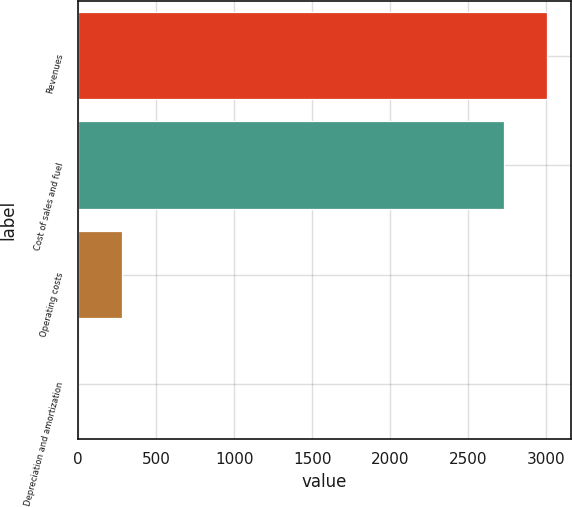Convert chart to OTSL. <chart><loc_0><loc_0><loc_500><loc_500><bar_chart><fcel>Revenues<fcel>Cost of sales and fuel<fcel>Operating costs<fcel>Depreciation and amortization<nl><fcel>3006.18<fcel>2728.5<fcel>278.08<fcel>0.4<nl></chart> 